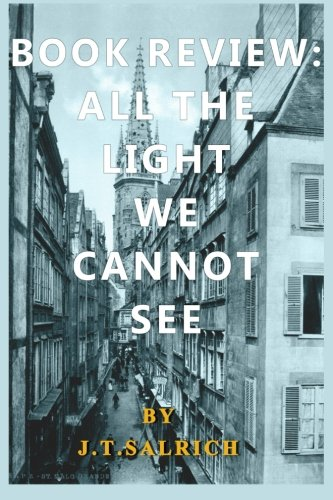Who wrote this book? The book 'All the Light We Cannot See' displayed in the image is authored by J.T. Salrich. 